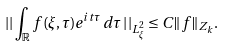Convert formula to latex. <formula><loc_0><loc_0><loc_500><loc_500>\left | \right | \int _ { \mathbb { R } } f ( \xi , \tau ) e ^ { i t \tau } \, d \tau \left | \right | _ { L ^ { 2 } _ { \xi } } \leq C \| f \| _ { Z _ { k } } .</formula> 